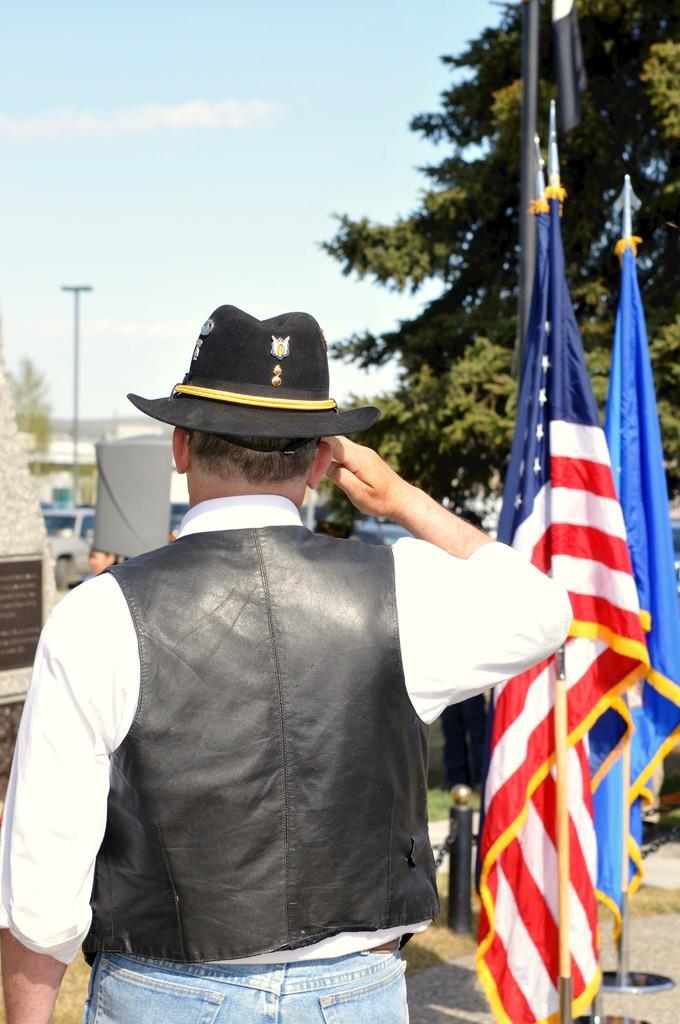Describe this image in one or two sentences. Inn the foreground we can see flags, cornerstone, grass and a person. In the middle there are trees, cars, person, pole and other objects. At the top there is sky. 